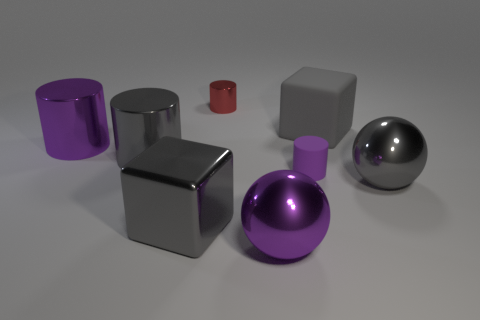There is a purple object in front of the gray metal thing that is in front of the large gray shiny ball that is right of the purple metallic cylinder; what is its material?
Provide a short and direct response. Metal. There is a block that is the same material as the small red cylinder; what size is it?
Keep it short and to the point. Large. What color is the small object that is in front of the purple cylinder behind the purple matte cylinder?
Your answer should be very brief. Purple. How many gray cubes are the same material as the big gray cylinder?
Give a very brief answer. 1. How many metallic objects are either blocks or large cylinders?
Keep it short and to the point. 3. What material is the purple ball that is the same size as the gray cylinder?
Offer a very short reply. Metal. Are there any large purple objects that have the same material as the red cylinder?
Make the answer very short. Yes. The big rubber thing behind the large cylinder that is in front of the purple cylinder on the left side of the large purple metallic sphere is what shape?
Keep it short and to the point. Cube. Is the size of the purple metallic ball the same as the cube that is behind the tiny rubber cylinder?
Provide a succinct answer. Yes. There is a big metal object that is behind the large gray metallic block and in front of the purple rubber cylinder; what is its shape?
Keep it short and to the point. Sphere. 